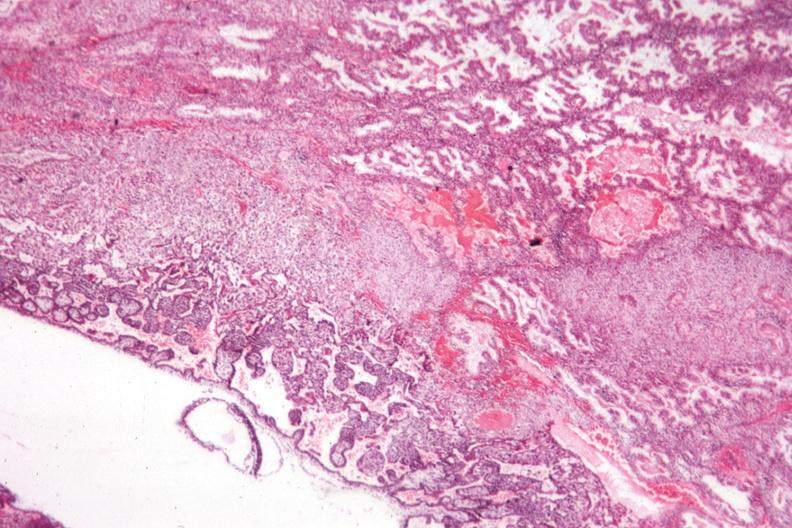what is present?
Answer the question using a single word or phrase. Female reproductive 